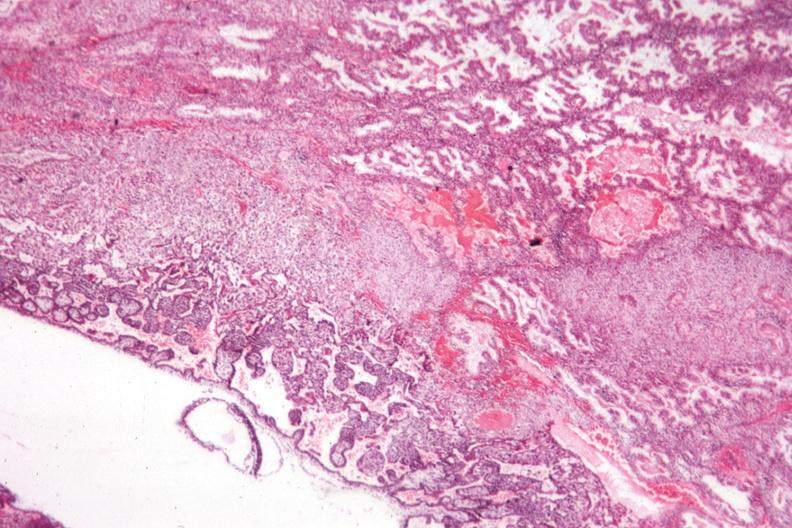what is present?
Answer the question using a single word or phrase. Female reproductive 